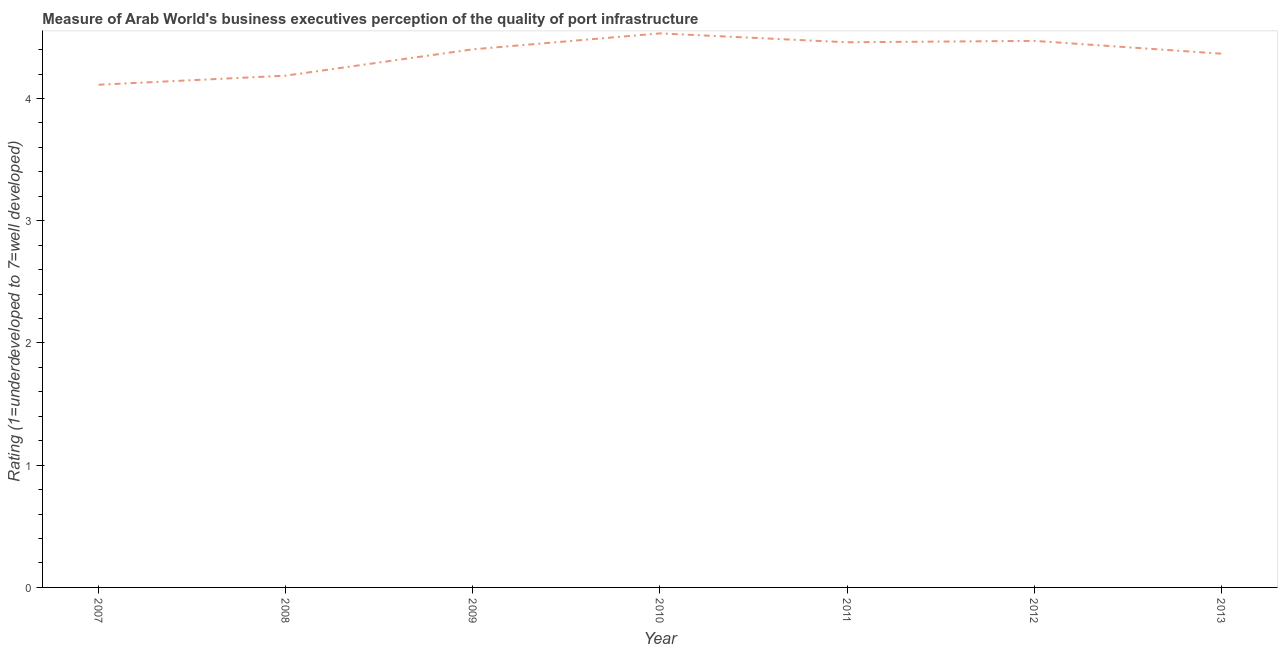What is the rating measuring quality of port infrastructure in 2007?
Your answer should be compact. 4.11. Across all years, what is the maximum rating measuring quality of port infrastructure?
Provide a succinct answer. 4.53. Across all years, what is the minimum rating measuring quality of port infrastructure?
Offer a terse response. 4.11. In which year was the rating measuring quality of port infrastructure maximum?
Provide a short and direct response. 2010. What is the sum of the rating measuring quality of port infrastructure?
Offer a terse response. 30.53. What is the difference between the rating measuring quality of port infrastructure in 2011 and 2012?
Provide a succinct answer. -0.01. What is the average rating measuring quality of port infrastructure per year?
Ensure brevity in your answer.  4.36. What is the median rating measuring quality of port infrastructure?
Your response must be concise. 4.4. In how many years, is the rating measuring quality of port infrastructure greater than 1.6 ?
Provide a short and direct response. 7. Do a majority of the years between 2010 and 2011 (inclusive) have rating measuring quality of port infrastructure greater than 3.2 ?
Make the answer very short. Yes. What is the ratio of the rating measuring quality of port infrastructure in 2009 to that in 2010?
Make the answer very short. 0.97. What is the difference between the highest and the second highest rating measuring quality of port infrastructure?
Ensure brevity in your answer.  0.06. What is the difference between the highest and the lowest rating measuring quality of port infrastructure?
Give a very brief answer. 0.42. In how many years, is the rating measuring quality of port infrastructure greater than the average rating measuring quality of port infrastructure taken over all years?
Give a very brief answer. 5. Are the values on the major ticks of Y-axis written in scientific E-notation?
Provide a succinct answer. No. What is the title of the graph?
Provide a succinct answer. Measure of Arab World's business executives perception of the quality of port infrastructure. What is the label or title of the X-axis?
Offer a terse response. Year. What is the label or title of the Y-axis?
Keep it short and to the point. Rating (1=underdeveloped to 7=well developed) . What is the Rating (1=underdeveloped to 7=well developed)  of 2007?
Provide a succinct answer. 4.11. What is the Rating (1=underdeveloped to 7=well developed)  in 2008?
Provide a short and direct response. 4.19. What is the Rating (1=underdeveloped to 7=well developed)  in 2009?
Give a very brief answer. 4.4. What is the Rating (1=underdeveloped to 7=well developed)  of 2010?
Keep it short and to the point. 4.53. What is the Rating (1=underdeveloped to 7=well developed)  in 2011?
Give a very brief answer. 4.46. What is the Rating (1=underdeveloped to 7=well developed)  of 2012?
Offer a terse response. 4.47. What is the Rating (1=underdeveloped to 7=well developed)  of 2013?
Your answer should be very brief. 4.37. What is the difference between the Rating (1=underdeveloped to 7=well developed)  in 2007 and 2008?
Provide a short and direct response. -0.07. What is the difference between the Rating (1=underdeveloped to 7=well developed)  in 2007 and 2009?
Ensure brevity in your answer.  -0.29. What is the difference between the Rating (1=underdeveloped to 7=well developed)  in 2007 and 2010?
Your answer should be compact. -0.42. What is the difference between the Rating (1=underdeveloped to 7=well developed)  in 2007 and 2011?
Your answer should be compact. -0.35. What is the difference between the Rating (1=underdeveloped to 7=well developed)  in 2007 and 2012?
Your answer should be compact. -0.36. What is the difference between the Rating (1=underdeveloped to 7=well developed)  in 2007 and 2013?
Give a very brief answer. -0.25. What is the difference between the Rating (1=underdeveloped to 7=well developed)  in 2008 and 2009?
Provide a succinct answer. -0.22. What is the difference between the Rating (1=underdeveloped to 7=well developed)  in 2008 and 2010?
Ensure brevity in your answer.  -0.35. What is the difference between the Rating (1=underdeveloped to 7=well developed)  in 2008 and 2011?
Provide a succinct answer. -0.27. What is the difference between the Rating (1=underdeveloped to 7=well developed)  in 2008 and 2012?
Your answer should be very brief. -0.28. What is the difference between the Rating (1=underdeveloped to 7=well developed)  in 2008 and 2013?
Provide a succinct answer. -0.18. What is the difference between the Rating (1=underdeveloped to 7=well developed)  in 2009 and 2010?
Your answer should be compact. -0.13. What is the difference between the Rating (1=underdeveloped to 7=well developed)  in 2009 and 2011?
Give a very brief answer. -0.06. What is the difference between the Rating (1=underdeveloped to 7=well developed)  in 2009 and 2012?
Your answer should be very brief. -0.07. What is the difference between the Rating (1=underdeveloped to 7=well developed)  in 2009 and 2013?
Make the answer very short. 0.04. What is the difference between the Rating (1=underdeveloped to 7=well developed)  in 2010 and 2011?
Your answer should be compact. 0.07. What is the difference between the Rating (1=underdeveloped to 7=well developed)  in 2010 and 2012?
Your response must be concise. 0.06. What is the difference between the Rating (1=underdeveloped to 7=well developed)  in 2010 and 2013?
Ensure brevity in your answer.  0.17. What is the difference between the Rating (1=underdeveloped to 7=well developed)  in 2011 and 2012?
Ensure brevity in your answer.  -0.01. What is the difference between the Rating (1=underdeveloped to 7=well developed)  in 2011 and 2013?
Your response must be concise. 0.09. What is the difference between the Rating (1=underdeveloped to 7=well developed)  in 2012 and 2013?
Make the answer very short. 0.1. What is the ratio of the Rating (1=underdeveloped to 7=well developed)  in 2007 to that in 2009?
Your response must be concise. 0.93. What is the ratio of the Rating (1=underdeveloped to 7=well developed)  in 2007 to that in 2010?
Your answer should be very brief. 0.91. What is the ratio of the Rating (1=underdeveloped to 7=well developed)  in 2007 to that in 2011?
Your answer should be compact. 0.92. What is the ratio of the Rating (1=underdeveloped to 7=well developed)  in 2007 to that in 2013?
Keep it short and to the point. 0.94. What is the ratio of the Rating (1=underdeveloped to 7=well developed)  in 2008 to that in 2009?
Your answer should be compact. 0.95. What is the ratio of the Rating (1=underdeveloped to 7=well developed)  in 2008 to that in 2010?
Offer a very short reply. 0.92. What is the ratio of the Rating (1=underdeveloped to 7=well developed)  in 2008 to that in 2011?
Give a very brief answer. 0.94. What is the ratio of the Rating (1=underdeveloped to 7=well developed)  in 2008 to that in 2012?
Provide a succinct answer. 0.94. What is the ratio of the Rating (1=underdeveloped to 7=well developed)  in 2009 to that in 2013?
Provide a succinct answer. 1.01. What is the ratio of the Rating (1=underdeveloped to 7=well developed)  in 2010 to that in 2013?
Provide a short and direct response. 1.04. What is the ratio of the Rating (1=underdeveloped to 7=well developed)  in 2012 to that in 2013?
Your response must be concise. 1.02. 